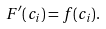Convert formula to latex. <formula><loc_0><loc_0><loc_500><loc_500>F ^ { \prime } ( c _ { i } ) = f ( c _ { i } ) .</formula> 